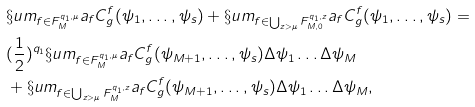Convert formula to latex. <formula><loc_0><loc_0><loc_500><loc_500>& \S u m _ { f \in F ^ { q _ { 1 } , \mu } _ { M } } a _ { f } C ^ { f } _ { g } ( \psi _ { 1 } , \dots , \psi _ { s } ) + \S u m _ { f \in \bigcup _ { z > \mu } F ^ { q _ { 1 } , z } _ { M , 0 } } a _ { f } C ^ { f } _ { g } ( \psi _ { 1 } , \dots , \psi _ { s } ) = \\ & ( \frac { 1 } { 2 } ) ^ { q _ { 1 } } \S u m _ { f \in F ^ { q _ { 1 } , \mu } _ { M } } a _ { f } C ^ { f } _ { g } ( \psi _ { M + 1 } , \dots , \psi _ { s } ) \Delta \psi _ { 1 } \dots \Delta \psi _ { M } \\ & + \S u m _ { f \in \bigcup _ { z > \mu } F ^ { q _ { 1 } , z } _ { M } } a _ { f } C ^ { f } _ { g } ( \psi _ { M + 1 } , \dots , \psi _ { s } ) \Delta \psi _ { 1 } \dots \Delta \psi _ { M } ,</formula> 